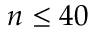<formula> <loc_0><loc_0><loc_500><loc_500>n \leq 4 0</formula> 